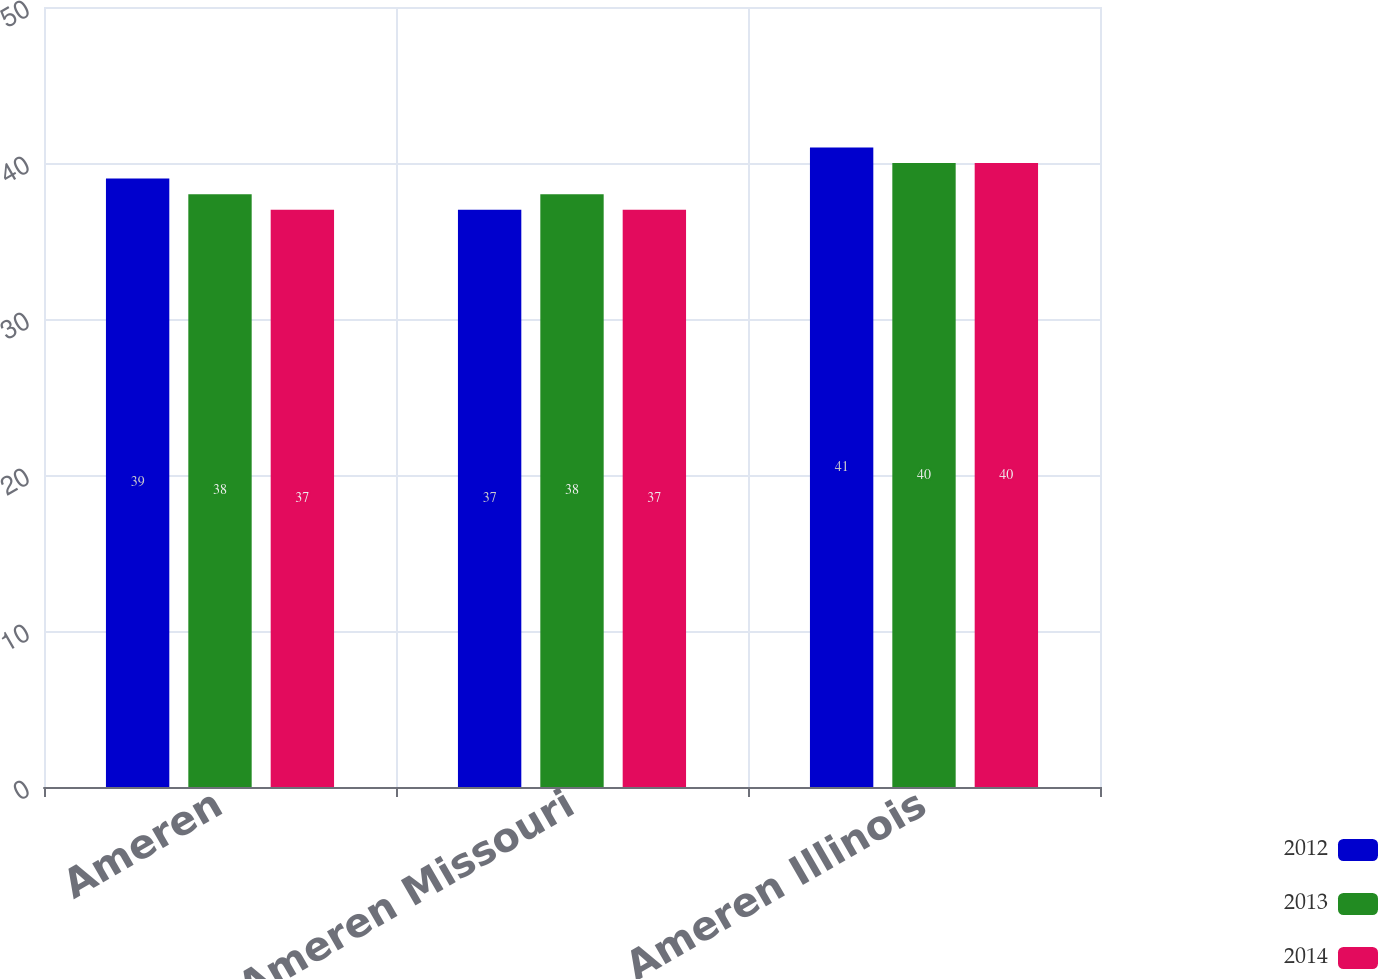Convert chart. <chart><loc_0><loc_0><loc_500><loc_500><stacked_bar_chart><ecel><fcel>Ameren<fcel>Ameren Missouri<fcel>Ameren Illinois<nl><fcel>2012<fcel>39<fcel>37<fcel>41<nl><fcel>2013<fcel>38<fcel>38<fcel>40<nl><fcel>2014<fcel>37<fcel>37<fcel>40<nl></chart> 